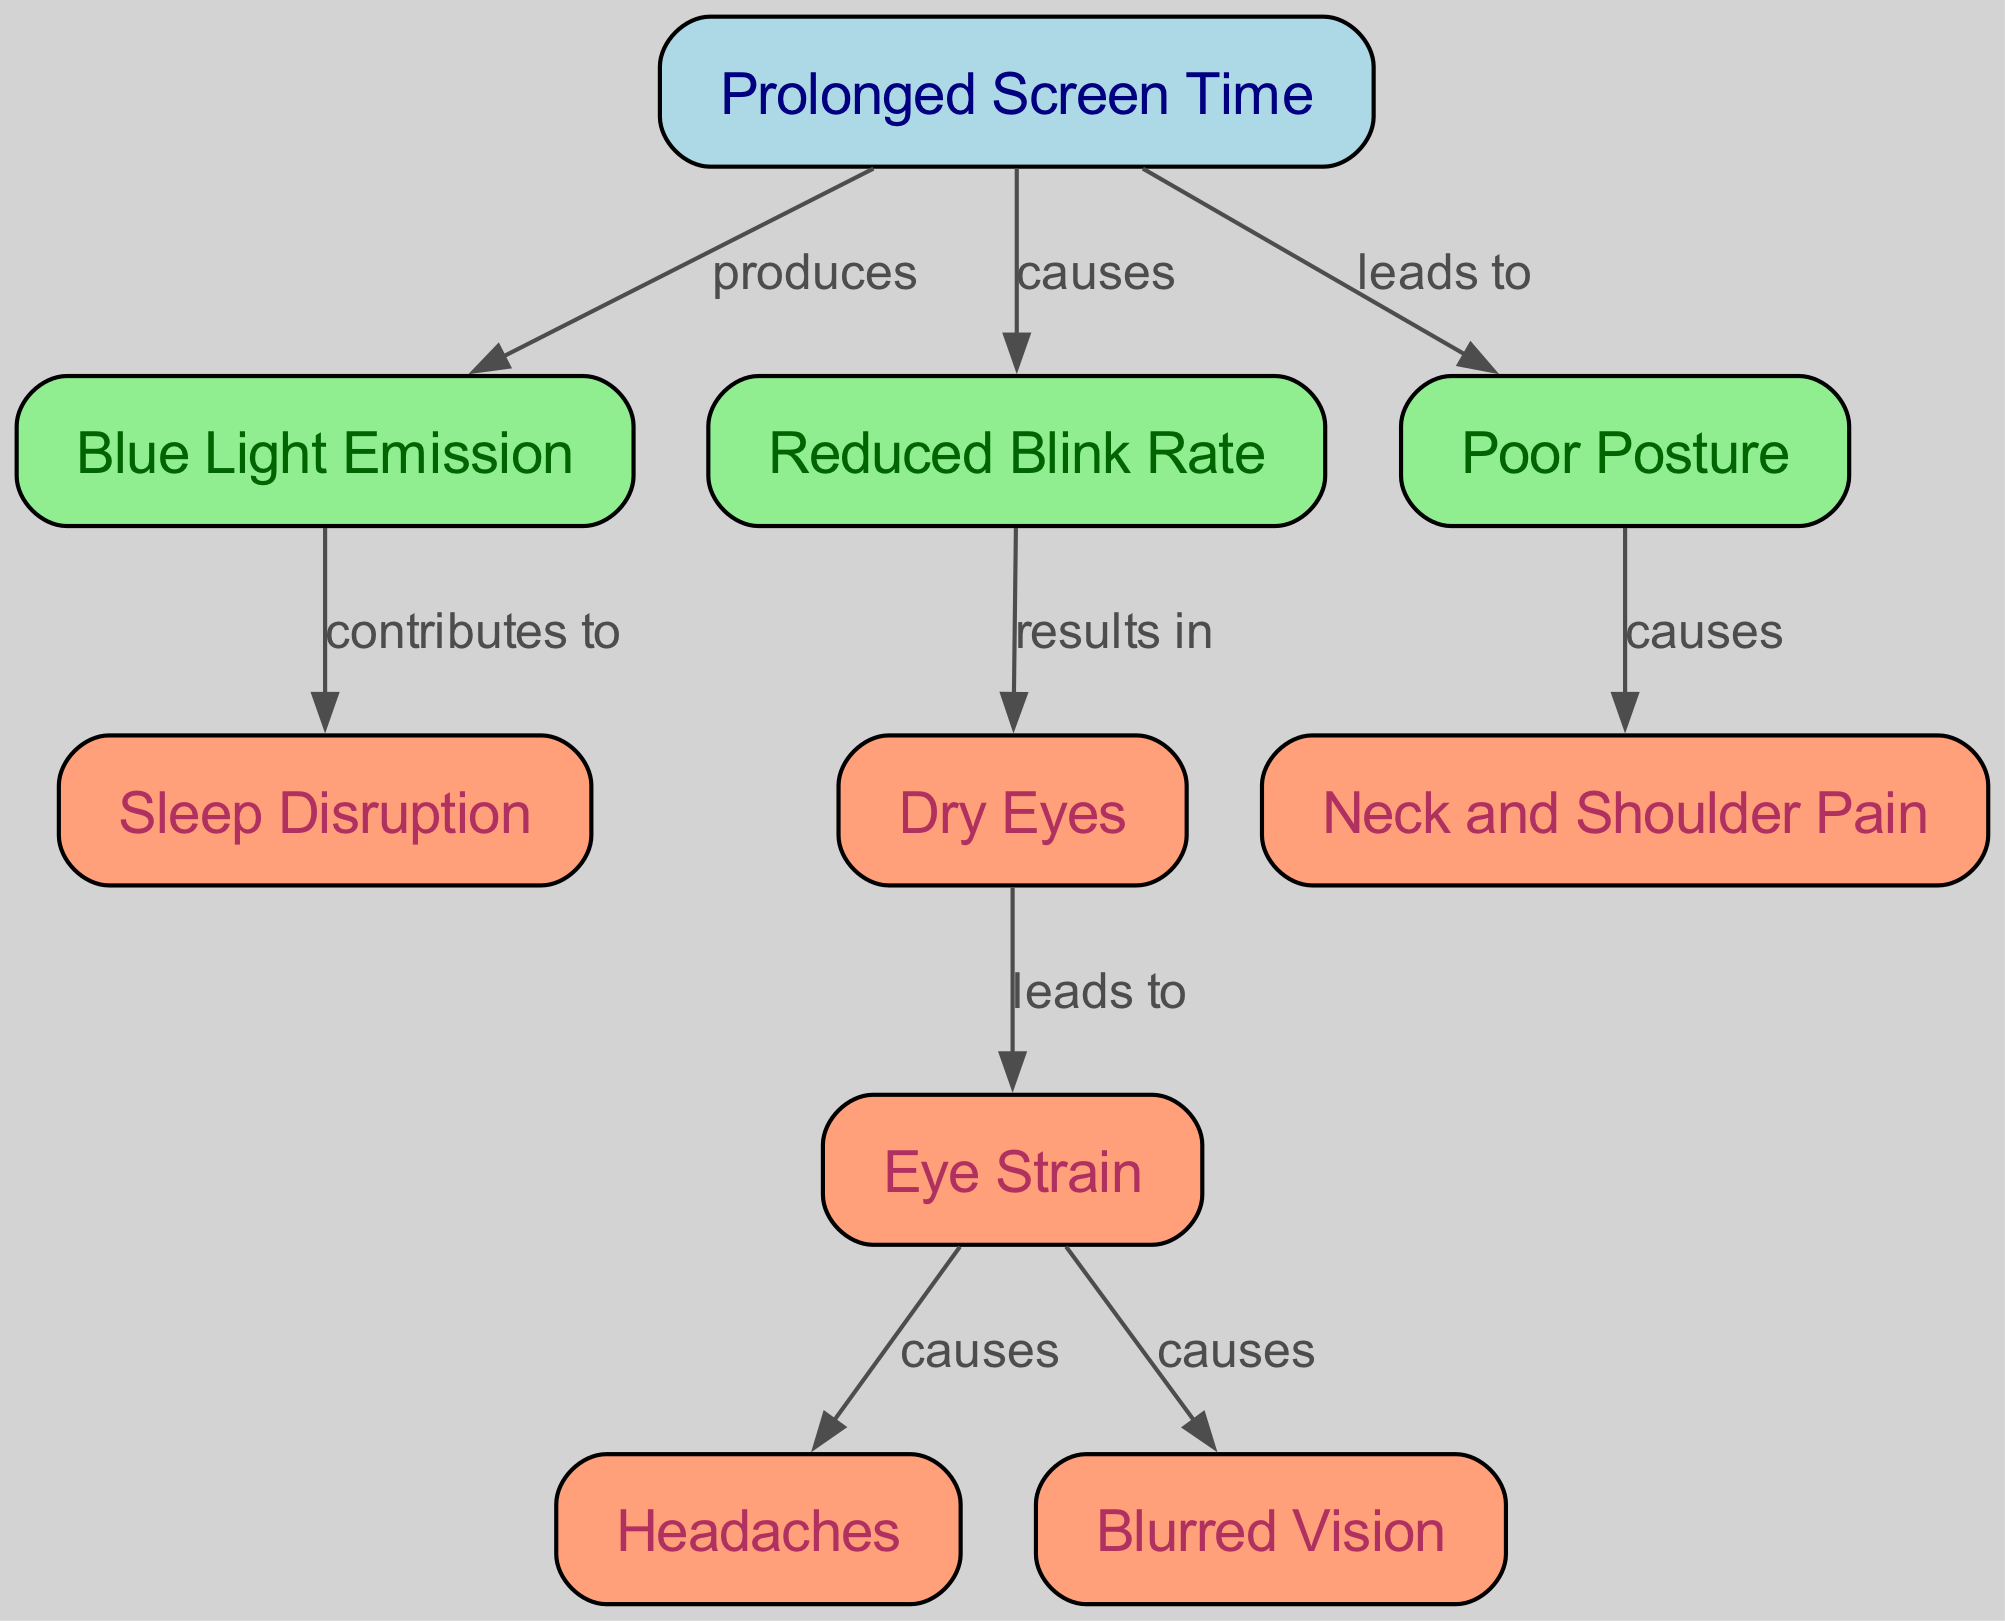What is the main cause of eye strain in this diagram? The diagram shows that eye strain results from dry eyes, which is indicated as leading to eye strain directly. Thus, the direct cause reflected in the diagram is dry eyes.
Answer: dry eyes How many nodes are present in the diagram? By counting the nodes listed, there are 10 nodes present in the diagram, each representing a different factor related to viewer fatigue and eye strain.
Answer: 10 What effect does blue light emission have according to the diagram? The diagram indicates that blue light emission contributes to sleep disruption, meaning its effect is indirectly related to sleep disturbances.
Answer: contributes to sleep disruption What leads to neck and shoulder pain? The diagram indicates that poor posture leads to neck and shoulder pain, emphasizing that the alignment and position of the body directly influence this condition.
Answer: leads to neck and shoulder pain Which factors cause blurred vision? The diagram shows that eye strain causes blurred vision directly, making eye strain the sole factor in this mapping.
Answer: causes What relationship exists between prolonged screen time and the reduced blink rate? The diagram illustrates that prolonged screen time causes a reduced blink rate, showing that as screen time increases, the blinking frequency decreases.
Answer: causes List all the conditions that result from eye strain. The diagram specifies that eye strain causes headaches and blurred vision, indicating that these conditions emerge as a direct result of experiencing eye strain.
Answer: headaches, blurred vision What is the effect of reduced blink rate on eye health? According to the diagram, a reduced blink rate results in dry eyes, indicating a negative effect on eye health due to insufficient lubrication and moisture.
Answer: results in dry eyes How does prolonged screen time relate to headaches? The diagram states that prolonged screen time leads to reduced blink rate, which in turn causes dry eyes; dry eyes then lead to eye strain, and finally, eye strain causes headaches. This sequence of causation outlines the complete relationship.
Answer: causes 